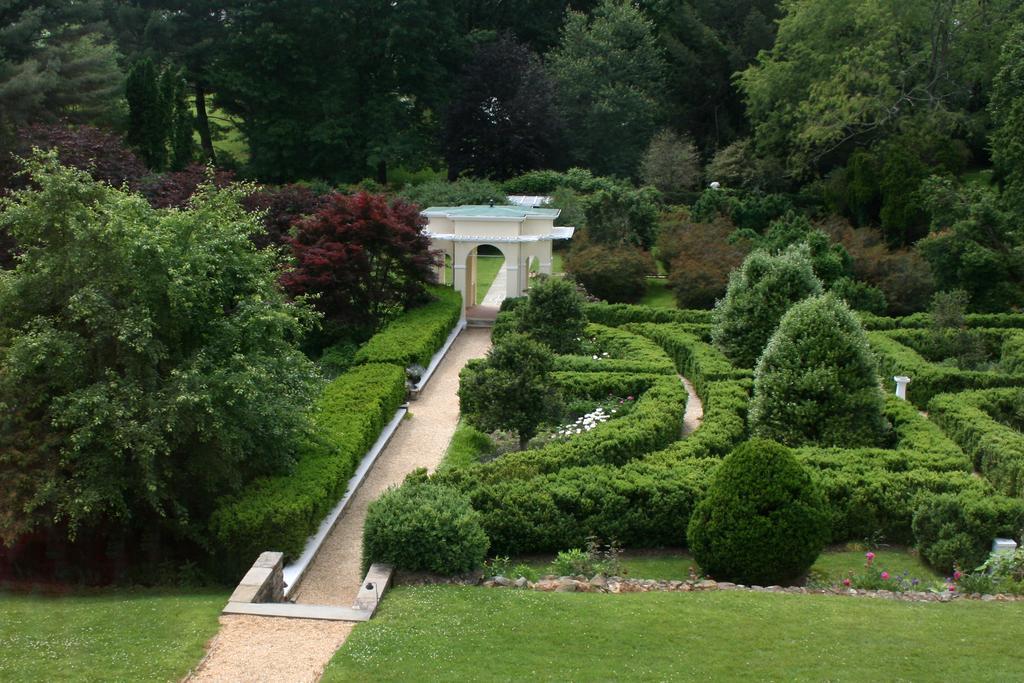Could you give a brief overview of what you see in this image? In this image in the front there's grass on the ground. In the center there are plants and flowers and there are stones. On the left side there are trees. In the background there is an arch and there are trees. 